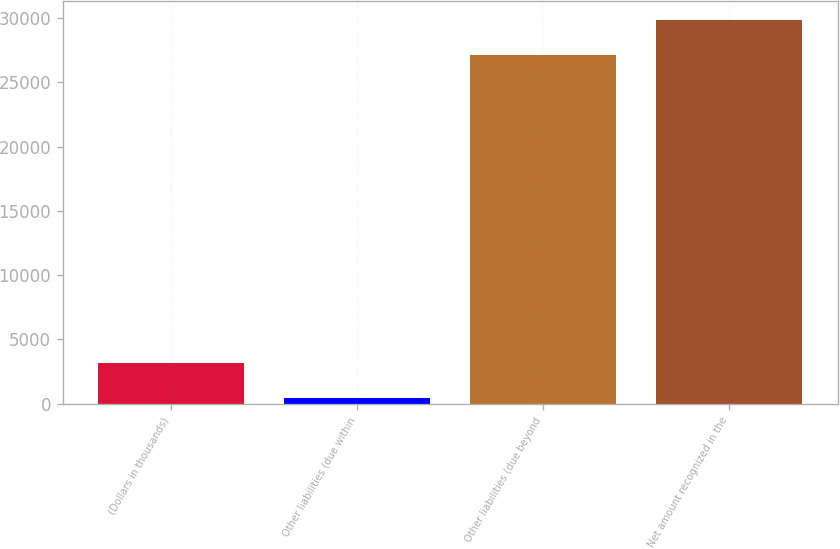Convert chart. <chart><loc_0><loc_0><loc_500><loc_500><bar_chart><fcel>(Dollars in thousands)<fcel>Other liabilities (due within<fcel>Other liabilities (due beyond<fcel>Net amount recognized in the<nl><fcel>3176.1<fcel>463<fcel>27130<fcel>29843.1<nl></chart> 